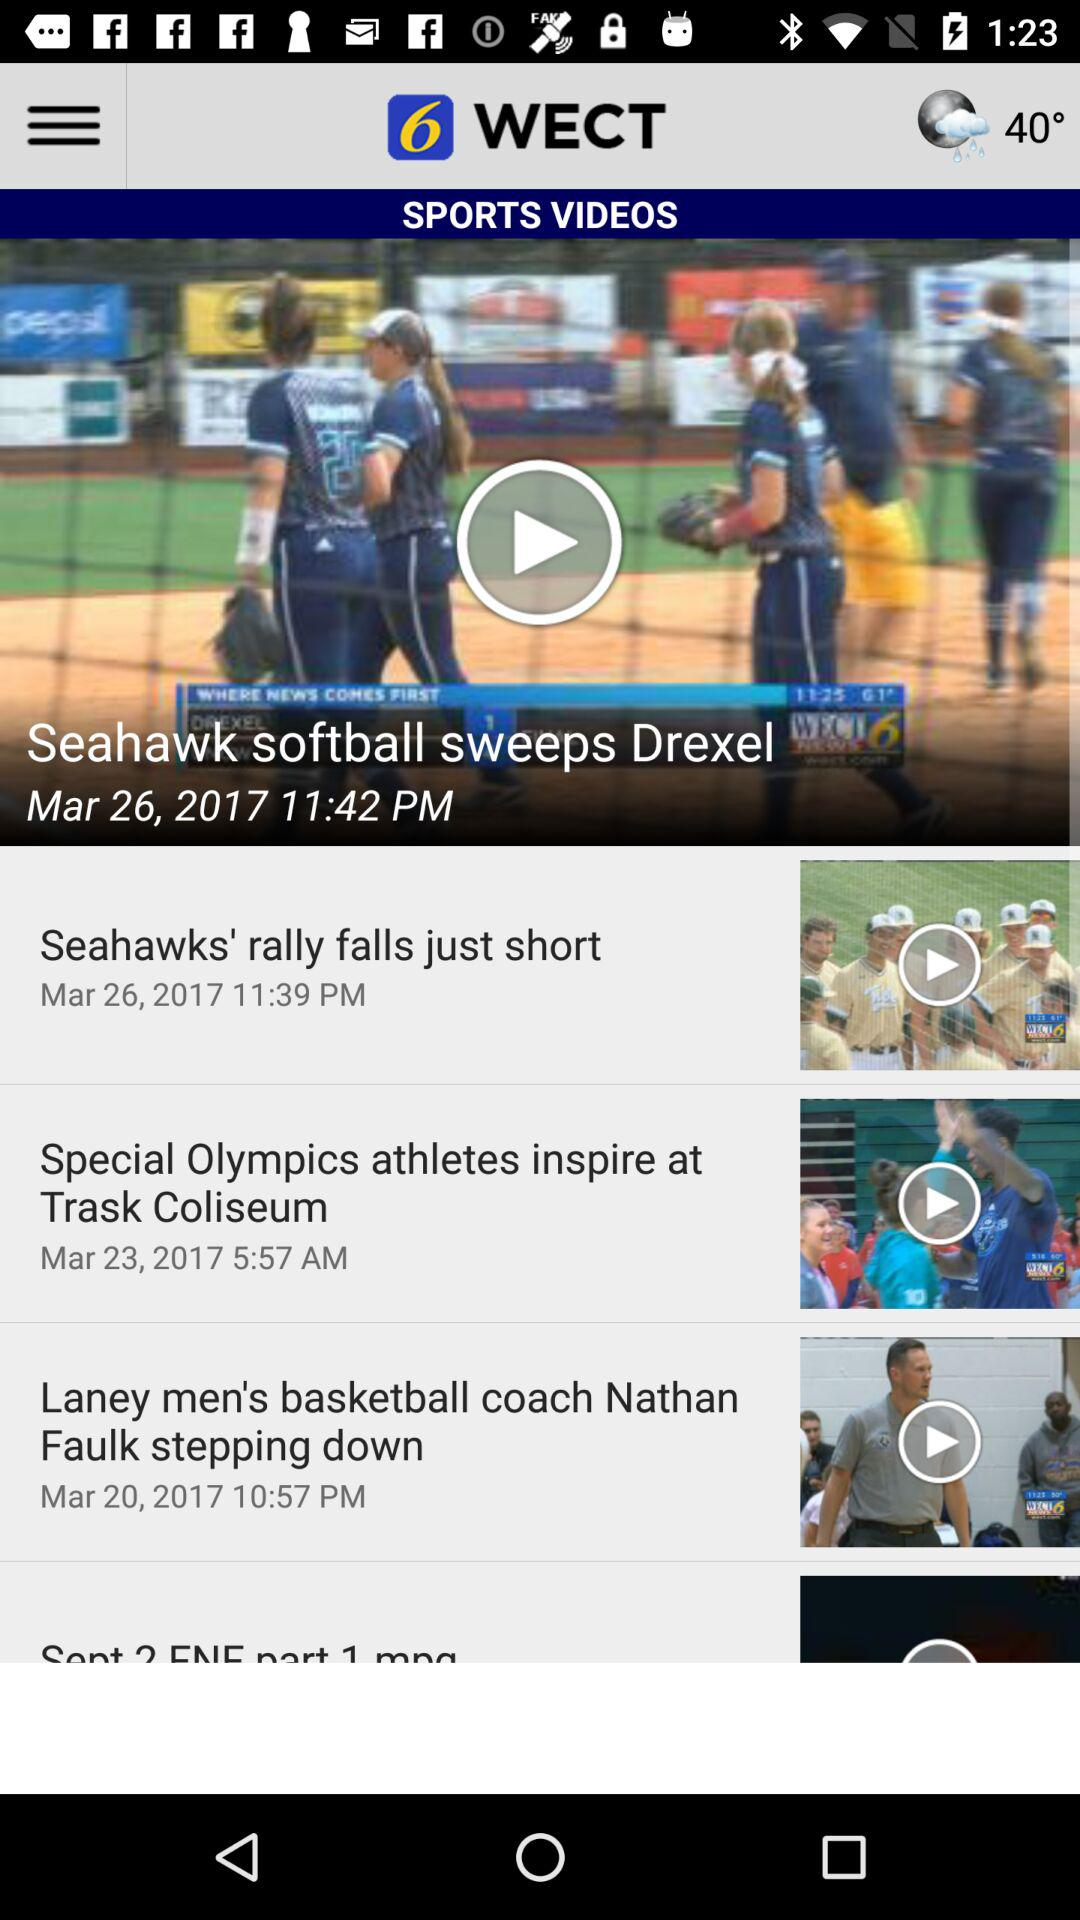On which date was the video "Seahawks' rally falls just short" uploaded? The video "Seahawks' rally falls just short" was uploaded on March 26, 2017. 